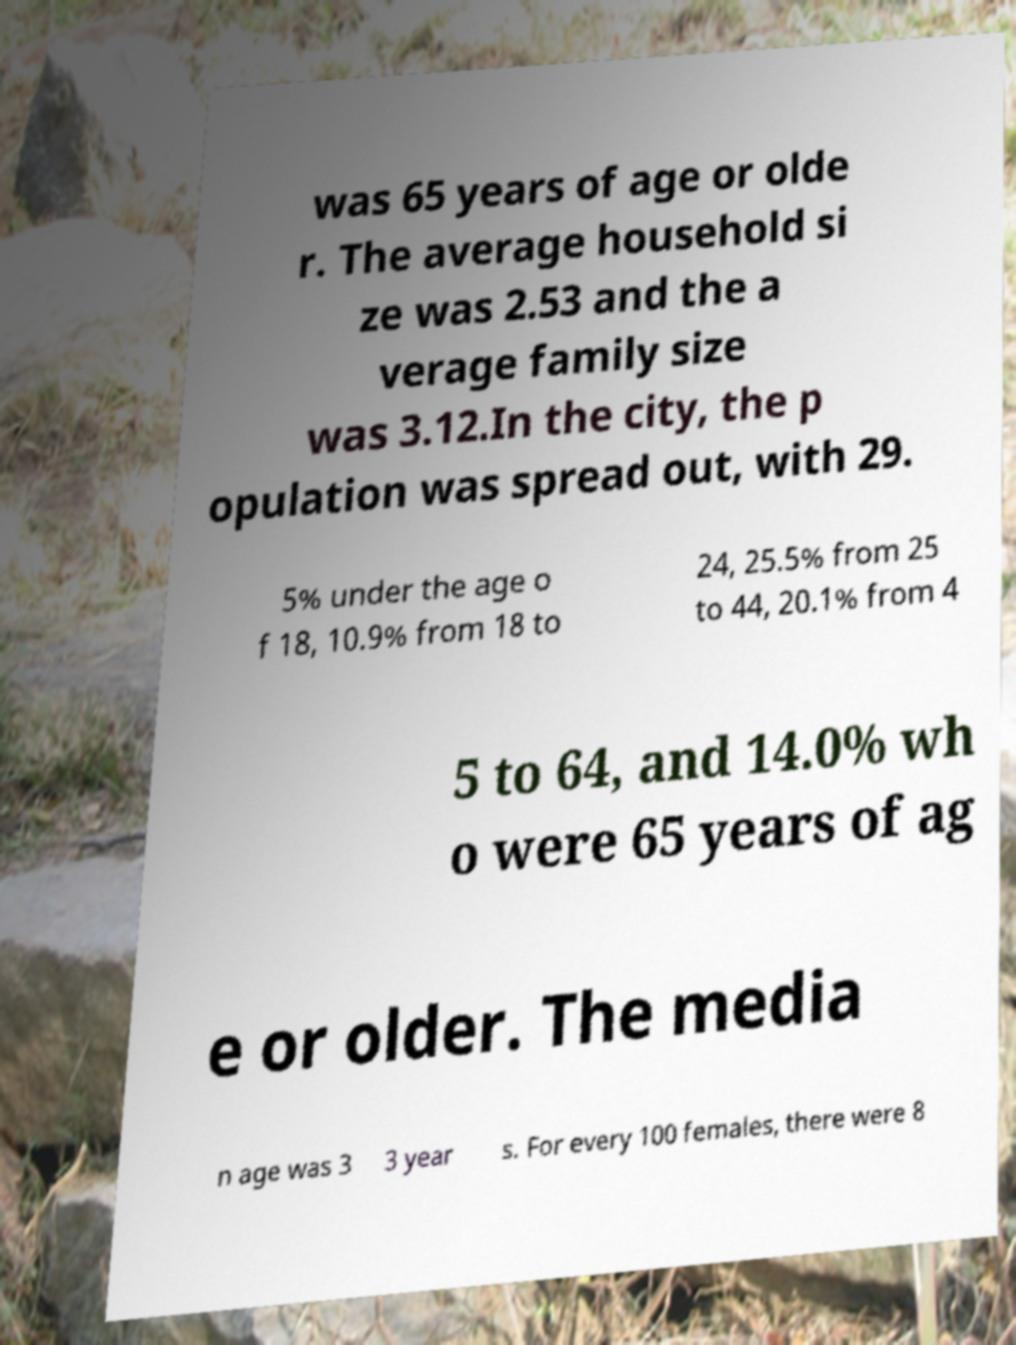There's text embedded in this image that I need extracted. Can you transcribe it verbatim? was 65 years of age or olde r. The average household si ze was 2.53 and the a verage family size was 3.12.In the city, the p opulation was spread out, with 29. 5% under the age o f 18, 10.9% from 18 to 24, 25.5% from 25 to 44, 20.1% from 4 5 to 64, and 14.0% wh o were 65 years of ag e or older. The media n age was 3 3 year s. For every 100 females, there were 8 